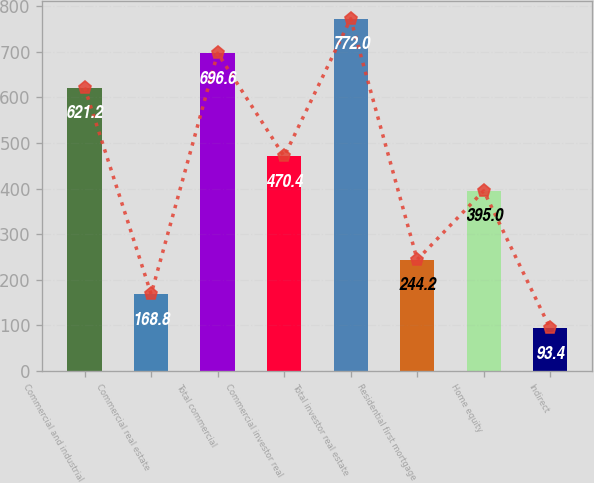<chart> <loc_0><loc_0><loc_500><loc_500><bar_chart><fcel>Commercial and industrial<fcel>Commercial real estate<fcel>Total commercial<fcel>Commercial investor real<fcel>Total investor real estate<fcel>Residential first mortgage<fcel>Home equity<fcel>Indirect<nl><fcel>621.2<fcel>168.8<fcel>696.6<fcel>470.4<fcel>772<fcel>244.2<fcel>395<fcel>93.4<nl></chart> 